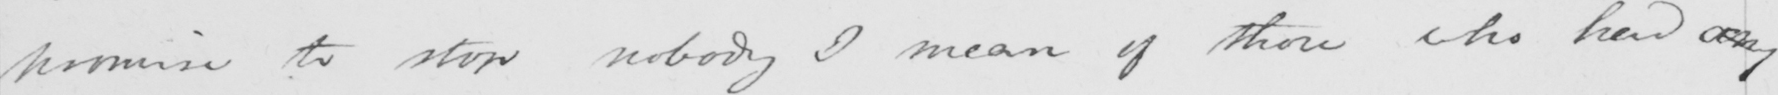Can you tell me what this handwritten text says? promise to stop nobody I mean of those who had any 